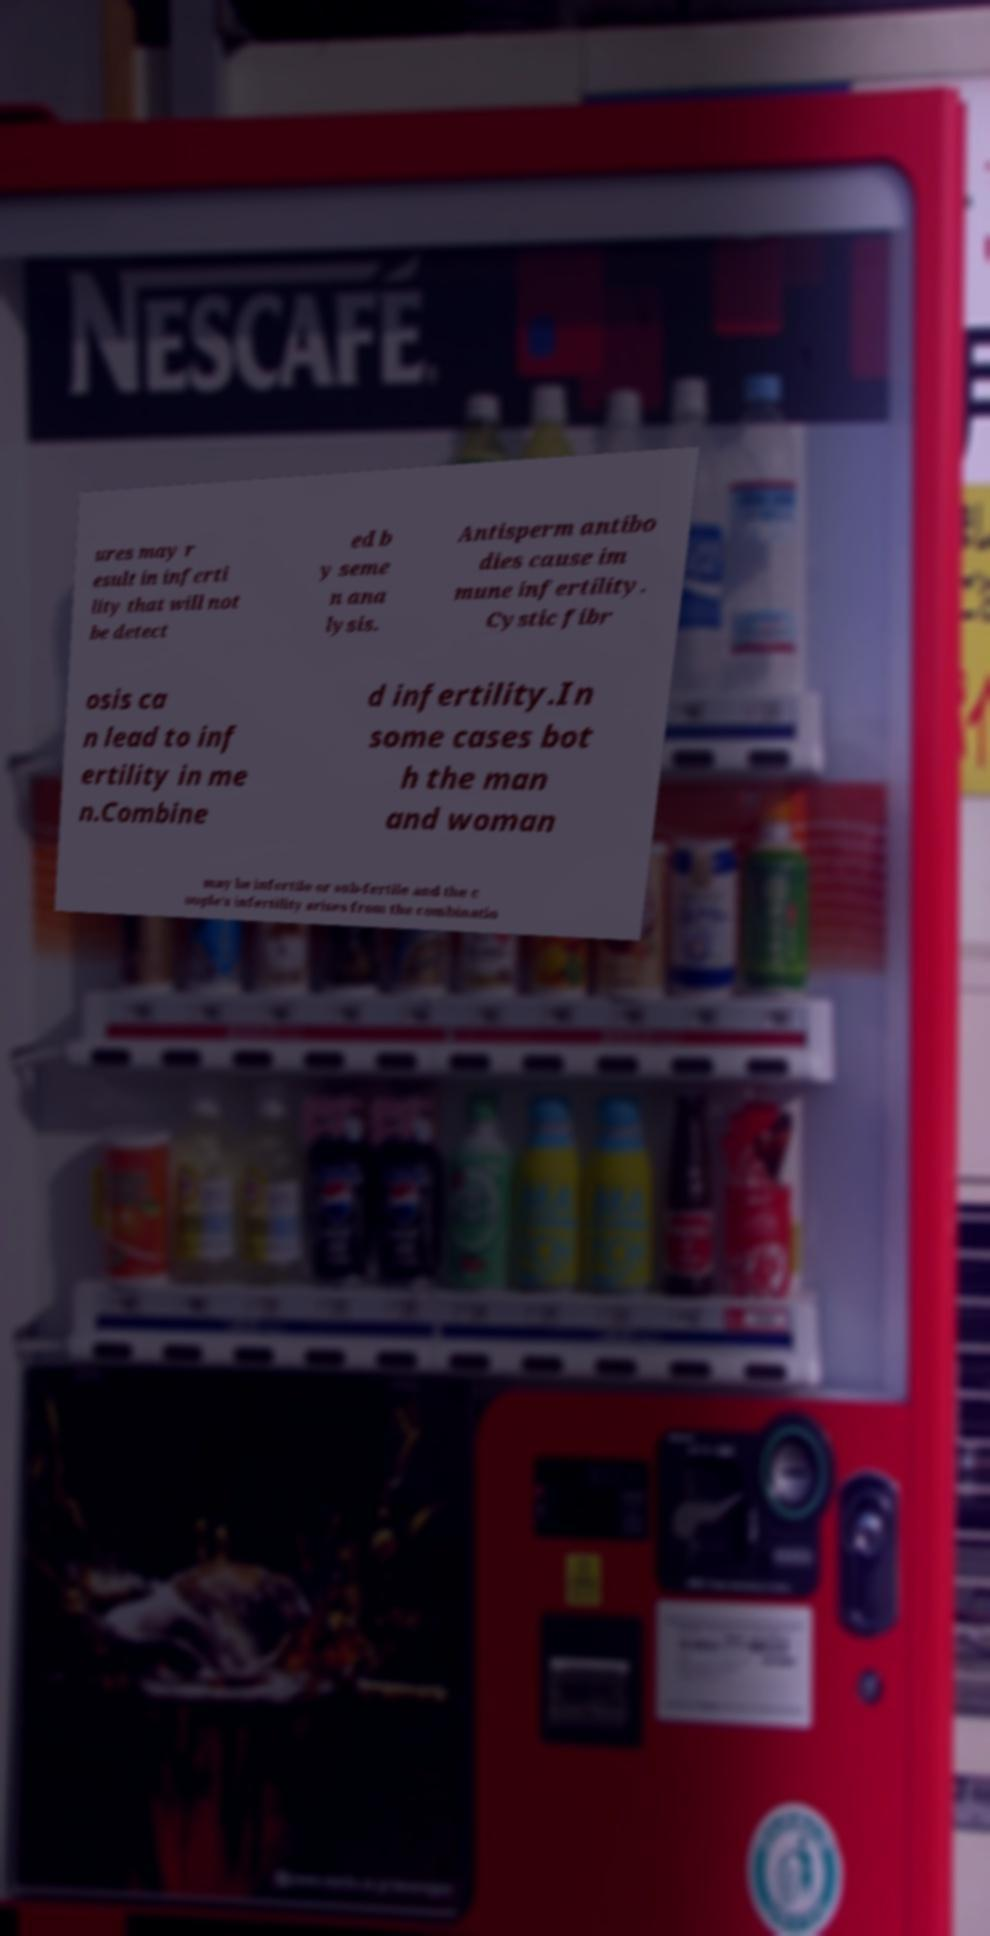Please identify and transcribe the text found in this image. ures may r esult in inferti lity that will not be detect ed b y seme n ana lysis. Antisperm antibo dies cause im mune infertility. Cystic fibr osis ca n lead to inf ertility in me n.Combine d infertility.In some cases bot h the man and woman may be infertile or sub-fertile and the c ouple's infertility arises from the combinatio 